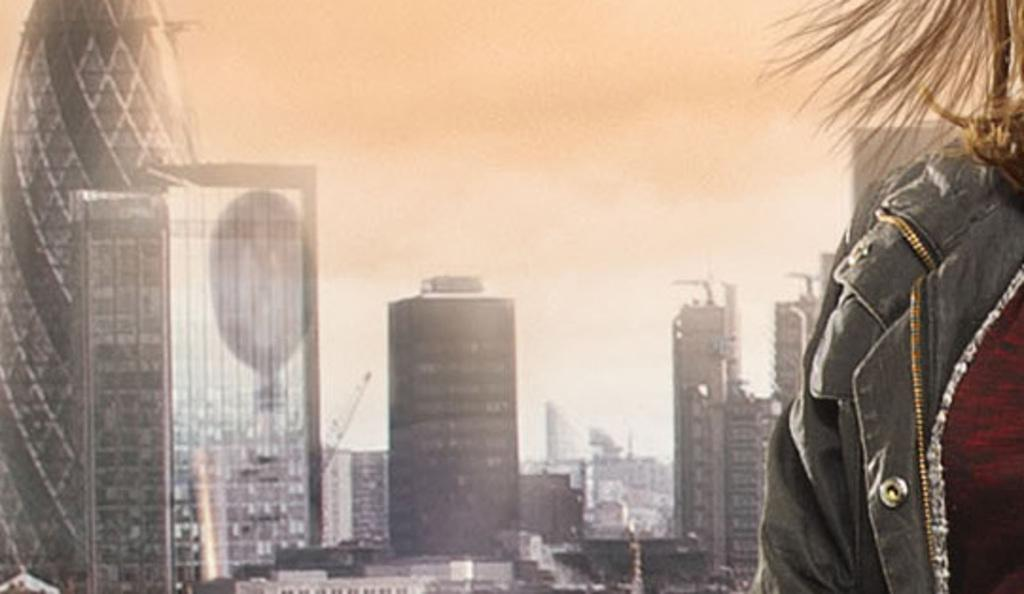What type of structures can be seen in the image? There are buildings in the image. Can you describe the person in the image? The person is wearing a black jacket. What is visible in the background of the image? The sky is visible in the image. What is the color of the sky in the image? The color of the sky is white. What is the rate of the trick being performed by the harbor in the image? There is no harbor or trick being performed in the image; it features buildings and a person wearing a black jacket with a white sky in the background. 